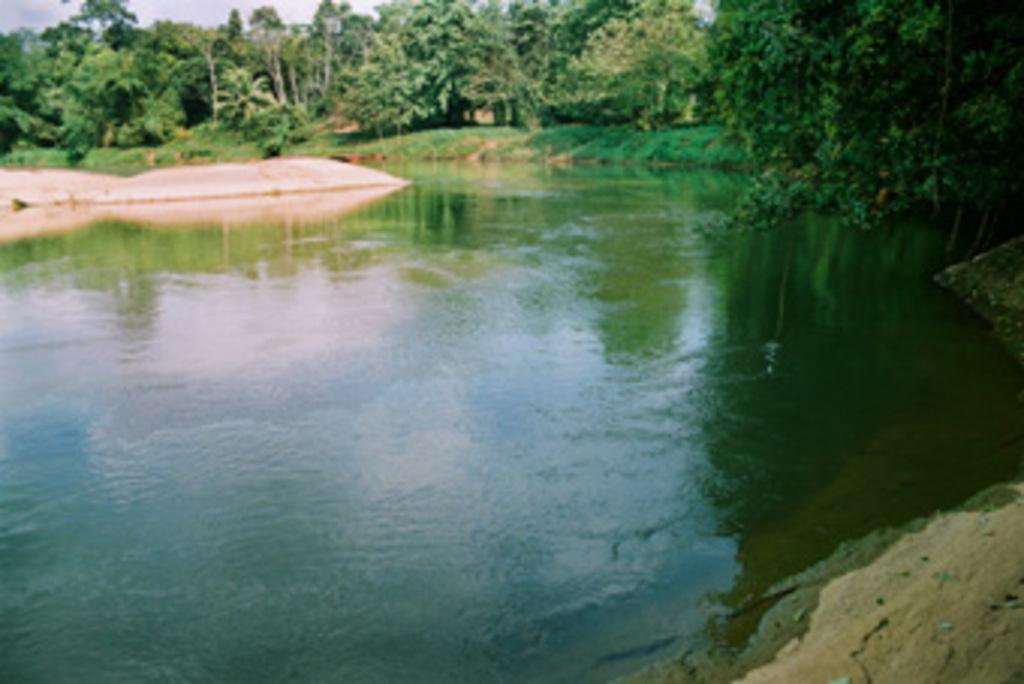What is present at the bottom of the image? There is water at the bottom of the image. What can be seen in the background of the image? There are trees in the background of the image. What type of vegetation is visible in the image? Grass is visible in the image. What part of the sky is visible in the image? The sky is visible at the top left of the image. What type of pickle is floating in the water in the image? There is no pickle present in the image; it only features water, trees, grass, and the sky. How does the authority of the trees affect the grass in the image? The image does not depict any authority or power dynamics between the trees and grass; it simply shows their coexistence in the scene. 